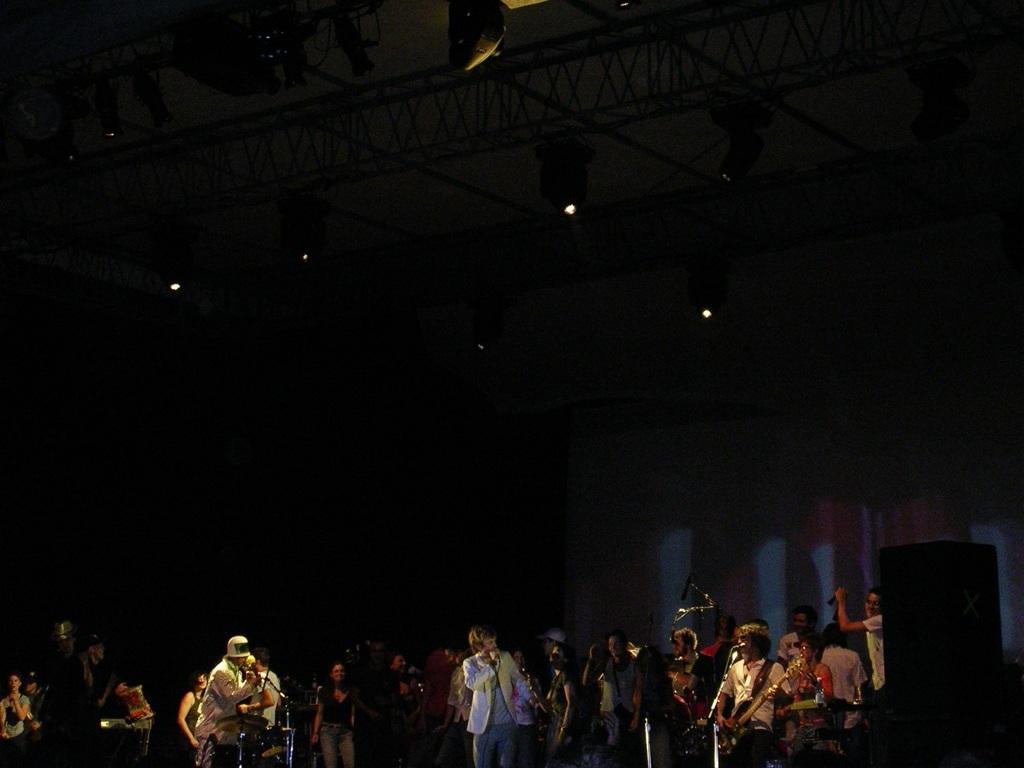Could you give a brief overview of what you see in this image? In this image there are many people on the stage. Few are singing, few are playing musical instruments. In the background there is a screen. This is a speaker on the bottom right. On the top there are lights. The background is dark. 